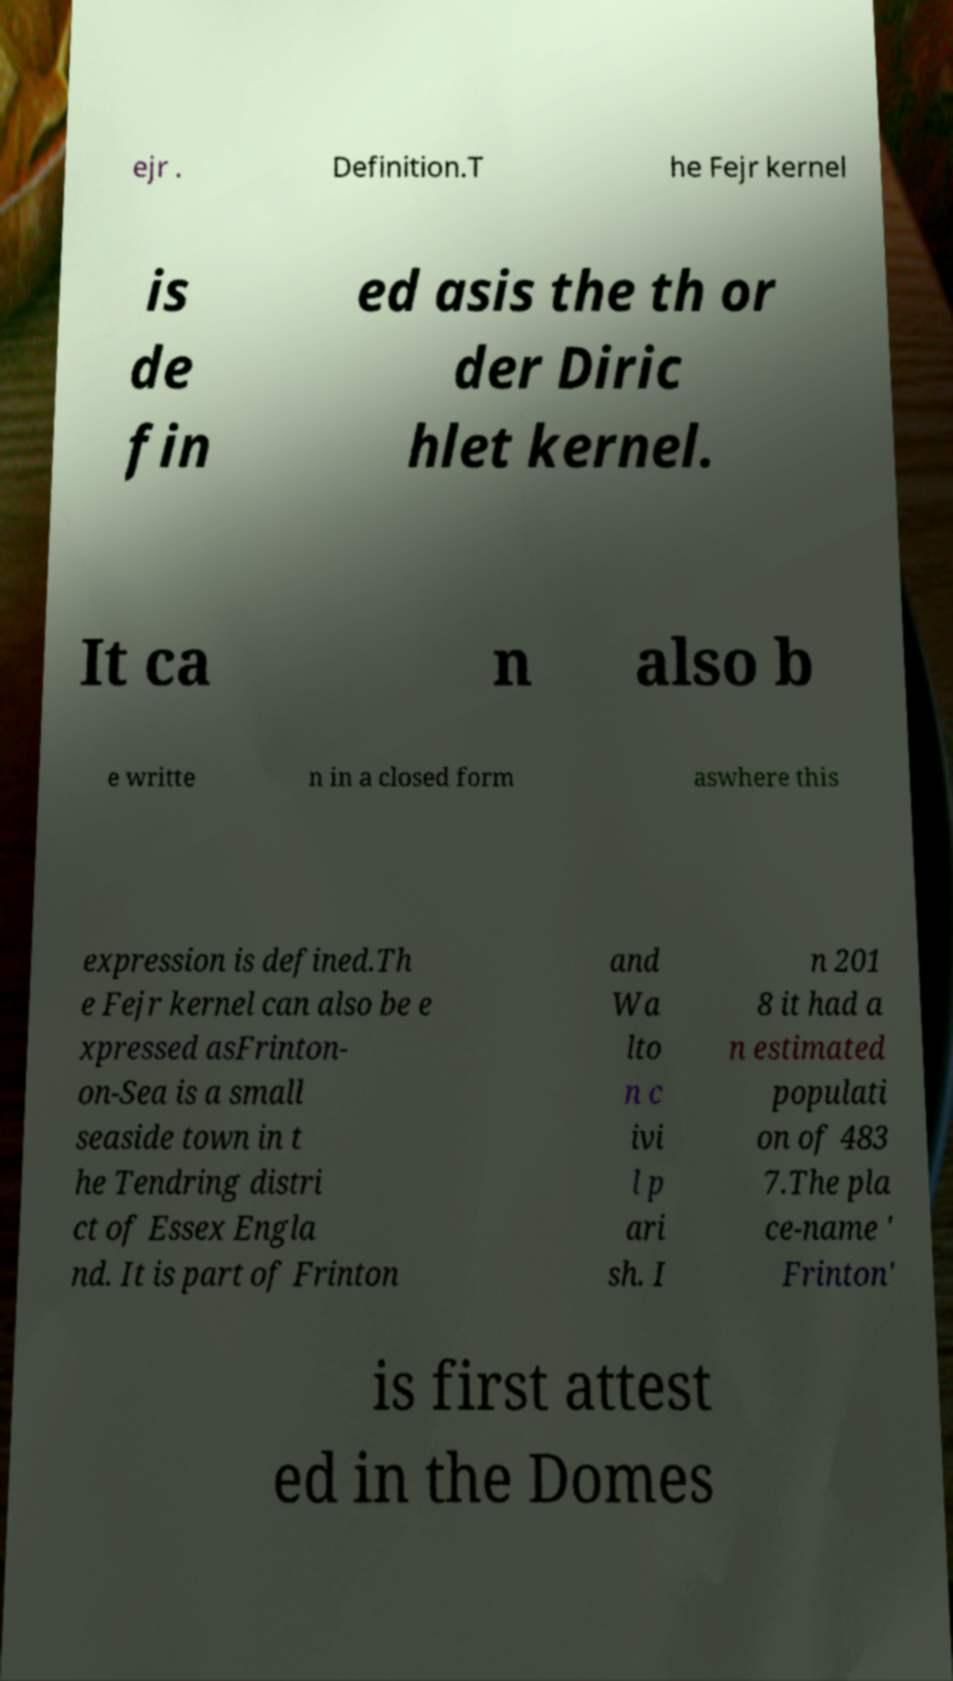For documentation purposes, I need the text within this image transcribed. Could you provide that? ejr . Definition.T he Fejr kernel is de fin ed asis the th or der Diric hlet kernel. It ca n also b e writte n in a closed form aswhere this expression is defined.Th e Fejr kernel can also be e xpressed asFrinton- on-Sea is a small seaside town in t he Tendring distri ct of Essex Engla nd. It is part of Frinton and Wa lto n c ivi l p ari sh. I n 201 8 it had a n estimated populati on of 483 7.The pla ce-name ' Frinton' is first attest ed in the Domes 